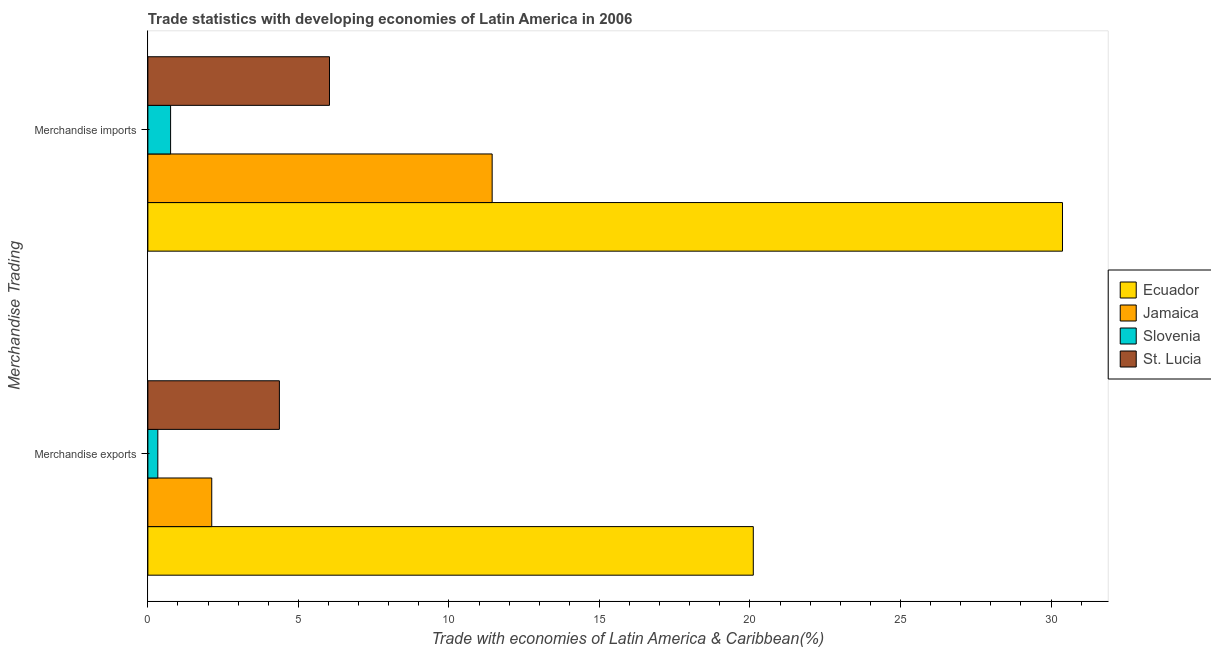How many groups of bars are there?
Keep it short and to the point. 2. Are the number of bars per tick equal to the number of legend labels?
Provide a short and direct response. Yes. Are the number of bars on each tick of the Y-axis equal?
Your response must be concise. Yes. How many bars are there on the 2nd tick from the top?
Your answer should be compact. 4. How many bars are there on the 2nd tick from the bottom?
Ensure brevity in your answer.  4. What is the label of the 1st group of bars from the top?
Provide a short and direct response. Merchandise imports. What is the merchandise exports in Jamaica?
Your response must be concise. 2.12. Across all countries, what is the maximum merchandise imports?
Your answer should be compact. 30.38. Across all countries, what is the minimum merchandise imports?
Provide a short and direct response. 0.75. In which country was the merchandise imports maximum?
Keep it short and to the point. Ecuador. In which country was the merchandise exports minimum?
Your response must be concise. Slovenia. What is the total merchandise exports in the graph?
Provide a succinct answer. 26.93. What is the difference between the merchandise exports in Slovenia and that in Ecuador?
Offer a terse response. -19.78. What is the difference between the merchandise imports in St. Lucia and the merchandise exports in Slovenia?
Your response must be concise. 5.7. What is the average merchandise imports per country?
Offer a very short reply. 12.15. What is the difference between the merchandise exports and merchandise imports in Slovenia?
Give a very brief answer. -0.42. In how many countries, is the merchandise exports greater than 27 %?
Keep it short and to the point. 0. What is the ratio of the merchandise imports in Ecuador to that in Slovenia?
Give a very brief answer. 40.25. What does the 2nd bar from the top in Merchandise exports represents?
Offer a terse response. Slovenia. What does the 3rd bar from the bottom in Merchandise exports represents?
Offer a terse response. Slovenia. Are all the bars in the graph horizontal?
Provide a short and direct response. Yes. What is the difference between two consecutive major ticks on the X-axis?
Your answer should be compact. 5. Are the values on the major ticks of X-axis written in scientific E-notation?
Offer a very short reply. No. Does the graph contain grids?
Give a very brief answer. No. Where does the legend appear in the graph?
Provide a short and direct response. Center right. What is the title of the graph?
Provide a succinct answer. Trade statistics with developing economies of Latin America in 2006. Does "Libya" appear as one of the legend labels in the graph?
Keep it short and to the point. No. What is the label or title of the X-axis?
Ensure brevity in your answer.  Trade with economies of Latin America & Caribbean(%). What is the label or title of the Y-axis?
Ensure brevity in your answer.  Merchandise Trading. What is the Trade with economies of Latin America & Caribbean(%) in Ecuador in Merchandise exports?
Keep it short and to the point. 20.11. What is the Trade with economies of Latin America & Caribbean(%) of Jamaica in Merchandise exports?
Your response must be concise. 2.12. What is the Trade with economies of Latin America & Caribbean(%) in Slovenia in Merchandise exports?
Keep it short and to the point. 0.33. What is the Trade with economies of Latin America & Caribbean(%) in St. Lucia in Merchandise exports?
Make the answer very short. 4.37. What is the Trade with economies of Latin America & Caribbean(%) in Ecuador in Merchandise imports?
Offer a very short reply. 30.38. What is the Trade with economies of Latin America & Caribbean(%) in Jamaica in Merchandise imports?
Your response must be concise. 11.44. What is the Trade with economies of Latin America & Caribbean(%) of Slovenia in Merchandise imports?
Provide a short and direct response. 0.75. What is the Trade with economies of Latin America & Caribbean(%) of St. Lucia in Merchandise imports?
Your response must be concise. 6.03. Across all Merchandise Trading, what is the maximum Trade with economies of Latin America & Caribbean(%) in Ecuador?
Provide a succinct answer. 30.38. Across all Merchandise Trading, what is the maximum Trade with economies of Latin America & Caribbean(%) in Jamaica?
Keep it short and to the point. 11.44. Across all Merchandise Trading, what is the maximum Trade with economies of Latin America & Caribbean(%) in Slovenia?
Provide a succinct answer. 0.75. Across all Merchandise Trading, what is the maximum Trade with economies of Latin America & Caribbean(%) of St. Lucia?
Offer a very short reply. 6.03. Across all Merchandise Trading, what is the minimum Trade with economies of Latin America & Caribbean(%) of Ecuador?
Give a very brief answer. 20.11. Across all Merchandise Trading, what is the minimum Trade with economies of Latin America & Caribbean(%) in Jamaica?
Offer a terse response. 2.12. Across all Merchandise Trading, what is the minimum Trade with economies of Latin America & Caribbean(%) of Slovenia?
Your answer should be very brief. 0.33. Across all Merchandise Trading, what is the minimum Trade with economies of Latin America & Caribbean(%) of St. Lucia?
Offer a terse response. 4.37. What is the total Trade with economies of Latin America & Caribbean(%) of Ecuador in the graph?
Ensure brevity in your answer.  50.49. What is the total Trade with economies of Latin America & Caribbean(%) of Jamaica in the graph?
Ensure brevity in your answer.  13.56. What is the total Trade with economies of Latin America & Caribbean(%) in Slovenia in the graph?
Your answer should be very brief. 1.09. What is the total Trade with economies of Latin America & Caribbean(%) in St. Lucia in the graph?
Ensure brevity in your answer.  10.4. What is the difference between the Trade with economies of Latin America & Caribbean(%) in Ecuador in Merchandise exports and that in Merchandise imports?
Provide a succinct answer. -10.27. What is the difference between the Trade with economies of Latin America & Caribbean(%) of Jamaica in Merchandise exports and that in Merchandise imports?
Make the answer very short. -9.31. What is the difference between the Trade with economies of Latin America & Caribbean(%) in Slovenia in Merchandise exports and that in Merchandise imports?
Provide a succinct answer. -0.42. What is the difference between the Trade with economies of Latin America & Caribbean(%) of St. Lucia in Merchandise exports and that in Merchandise imports?
Your answer should be compact. -1.66. What is the difference between the Trade with economies of Latin America & Caribbean(%) of Ecuador in Merchandise exports and the Trade with economies of Latin America & Caribbean(%) of Jamaica in Merchandise imports?
Make the answer very short. 8.67. What is the difference between the Trade with economies of Latin America & Caribbean(%) in Ecuador in Merchandise exports and the Trade with economies of Latin America & Caribbean(%) in Slovenia in Merchandise imports?
Keep it short and to the point. 19.36. What is the difference between the Trade with economies of Latin America & Caribbean(%) of Ecuador in Merchandise exports and the Trade with economies of Latin America & Caribbean(%) of St. Lucia in Merchandise imports?
Offer a very short reply. 14.08. What is the difference between the Trade with economies of Latin America & Caribbean(%) in Jamaica in Merchandise exports and the Trade with economies of Latin America & Caribbean(%) in Slovenia in Merchandise imports?
Your answer should be very brief. 1.37. What is the difference between the Trade with economies of Latin America & Caribbean(%) of Jamaica in Merchandise exports and the Trade with economies of Latin America & Caribbean(%) of St. Lucia in Merchandise imports?
Provide a short and direct response. -3.91. What is the difference between the Trade with economies of Latin America & Caribbean(%) of Slovenia in Merchandise exports and the Trade with economies of Latin America & Caribbean(%) of St. Lucia in Merchandise imports?
Your answer should be very brief. -5.7. What is the average Trade with economies of Latin America & Caribbean(%) in Ecuador per Merchandise Trading?
Offer a terse response. 25.25. What is the average Trade with economies of Latin America & Caribbean(%) in Jamaica per Merchandise Trading?
Offer a very short reply. 6.78. What is the average Trade with economies of Latin America & Caribbean(%) in Slovenia per Merchandise Trading?
Ensure brevity in your answer.  0.54. What is the average Trade with economies of Latin America & Caribbean(%) of St. Lucia per Merchandise Trading?
Provide a short and direct response. 5.2. What is the difference between the Trade with economies of Latin America & Caribbean(%) of Ecuador and Trade with economies of Latin America & Caribbean(%) of Jamaica in Merchandise exports?
Give a very brief answer. 17.99. What is the difference between the Trade with economies of Latin America & Caribbean(%) of Ecuador and Trade with economies of Latin America & Caribbean(%) of Slovenia in Merchandise exports?
Keep it short and to the point. 19.78. What is the difference between the Trade with economies of Latin America & Caribbean(%) in Ecuador and Trade with economies of Latin America & Caribbean(%) in St. Lucia in Merchandise exports?
Provide a succinct answer. 15.74. What is the difference between the Trade with economies of Latin America & Caribbean(%) of Jamaica and Trade with economies of Latin America & Caribbean(%) of Slovenia in Merchandise exports?
Your answer should be very brief. 1.79. What is the difference between the Trade with economies of Latin America & Caribbean(%) of Jamaica and Trade with economies of Latin America & Caribbean(%) of St. Lucia in Merchandise exports?
Your answer should be compact. -2.25. What is the difference between the Trade with economies of Latin America & Caribbean(%) in Slovenia and Trade with economies of Latin America & Caribbean(%) in St. Lucia in Merchandise exports?
Your answer should be compact. -4.04. What is the difference between the Trade with economies of Latin America & Caribbean(%) of Ecuador and Trade with economies of Latin America & Caribbean(%) of Jamaica in Merchandise imports?
Give a very brief answer. 18.94. What is the difference between the Trade with economies of Latin America & Caribbean(%) in Ecuador and Trade with economies of Latin America & Caribbean(%) in Slovenia in Merchandise imports?
Make the answer very short. 29.63. What is the difference between the Trade with economies of Latin America & Caribbean(%) of Ecuador and Trade with economies of Latin America & Caribbean(%) of St. Lucia in Merchandise imports?
Keep it short and to the point. 24.35. What is the difference between the Trade with economies of Latin America & Caribbean(%) in Jamaica and Trade with economies of Latin America & Caribbean(%) in Slovenia in Merchandise imports?
Your response must be concise. 10.68. What is the difference between the Trade with economies of Latin America & Caribbean(%) in Jamaica and Trade with economies of Latin America & Caribbean(%) in St. Lucia in Merchandise imports?
Make the answer very short. 5.4. What is the difference between the Trade with economies of Latin America & Caribbean(%) in Slovenia and Trade with economies of Latin America & Caribbean(%) in St. Lucia in Merchandise imports?
Keep it short and to the point. -5.28. What is the ratio of the Trade with economies of Latin America & Caribbean(%) in Ecuador in Merchandise exports to that in Merchandise imports?
Your answer should be very brief. 0.66. What is the ratio of the Trade with economies of Latin America & Caribbean(%) in Jamaica in Merchandise exports to that in Merchandise imports?
Your answer should be compact. 0.19. What is the ratio of the Trade with economies of Latin America & Caribbean(%) of Slovenia in Merchandise exports to that in Merchandise imports?
Your response must be concise. 0.44. What is the ratio of the Trade with economies of Latin America & Caribbean(%) of St. Lucia in Merchandise exports to that in Merchandise imports?
Your answer should be compact. 0.72. What is the difference between the highest and the second highest Trade with economies of Latin America & Caribbean(%) of Ecuador?
Offer a terse response. 10.27. What is the difference between the highest and the second highest Trade with economies of Latin America & Caribbean(%) in Jamaica?
Offer a very short reply. 9.31. What is the difference between the highest and the second highest Trade with economies of Latin America & Caribbean(%) in Slovenia?
Offer a very short reply. 0.42. What is the difference between the highest and the second highest Trade with economies of Latin America & Caribbean(%) in St. Lucia?
Your answer should be very brief. 1.66. What is the difference between the highest and the lowest Trade with economies of Latin America & Caribbean(%) of Ecuador?
Give a very brief answer. 10.27. What is the difference between the highest and the lowest Trade with economies of Latin America & Caribbean(%) in Jamaica?
Provide a succinct answer. 9.31. What is the difference between the highest and the lowest Trade with economies of Latin America & Caribbean(%) in Slovenia?
Offer a very short reply. 0.42. What is the difference between the highest and the lowest Trade with economies of Latin America & Caribbean(%) of St. Lucia?
Keep it short and to the point. 1.66. 